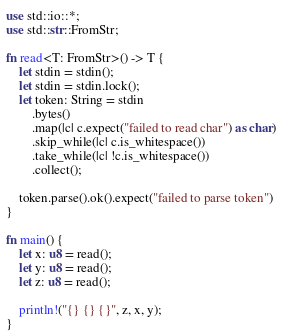<code> <loc_0><loc_0><loc_500><loc_500><_Rust_>use std::io::*;
use std::str::FromStr;

fn read<T: FromStr>() -> T {
    let stdin = stdin();
    let stdin = stdin.lock();
    let token: String = stdin
        .bytes()
        .map(|c| c.expect("failed to read char") as char)
        .skip_while(|c| c.is_whitespace())
        .take_while(|c| !c.is_whitespace())
        .collect();

    token.parse().ok().expect("failed to parse token")
}

fn main() {
    let x: u8 = read();
    let y: u8 = read();
    let z: u8 = read();

    println!("{} {} {}", z, x, y);
}
</code> 